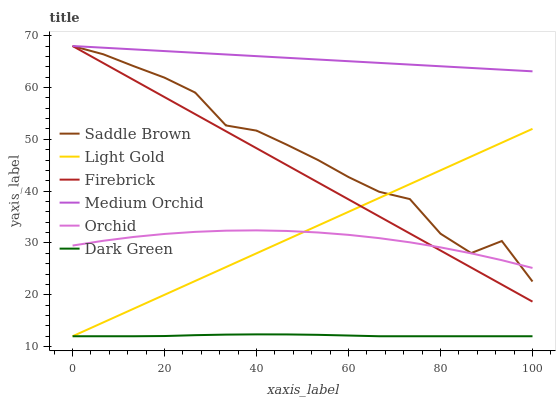Does Dark Green have the minimum area under the curve?
Answer yes or no. Yes. Does Medium Orchid have the maximum area under the curve?
Answer yes or no. Yes. Does Orchid have the minimum area under the curve?
Answer yes or no. No. Does Orchid have the maximum area under the curve?
Answer yes or no. No. Is Light Gold the smoothest?
Answer yes or no. Yes. Is Saddle Brown the roughest?
Answer yes or no. Yes. Is Medium Orchid the smoothest?
Answer yes or no. No. Is Medium Orchid the roughest?
Answer yes or no. No. Does Light Gold have the lowest value?
Answer yes or no. Yes. Does Orchid have the lowest value?
Answer yes or no. No. Does Saddle Brown have the highest value?
Answer yes or no. Yes. Does Orchid have the highest value?
Answer yes or no. No. Is Dark Green less than Orchid?
Answer yes or no. Yes. Is Firebrick greater than Dark Green?
Answer yes or no. Yes. Does Saddle Brown intersect Orchid?
Answer yes or no. Yes. Is Saddle Brown less than Orchid?
Answer yes or no. No. Is Saddle Brown greater than Orchid?
Answer yes or no. No. Does Dark Green intersect Orchid?
Answer yes or no. No. 